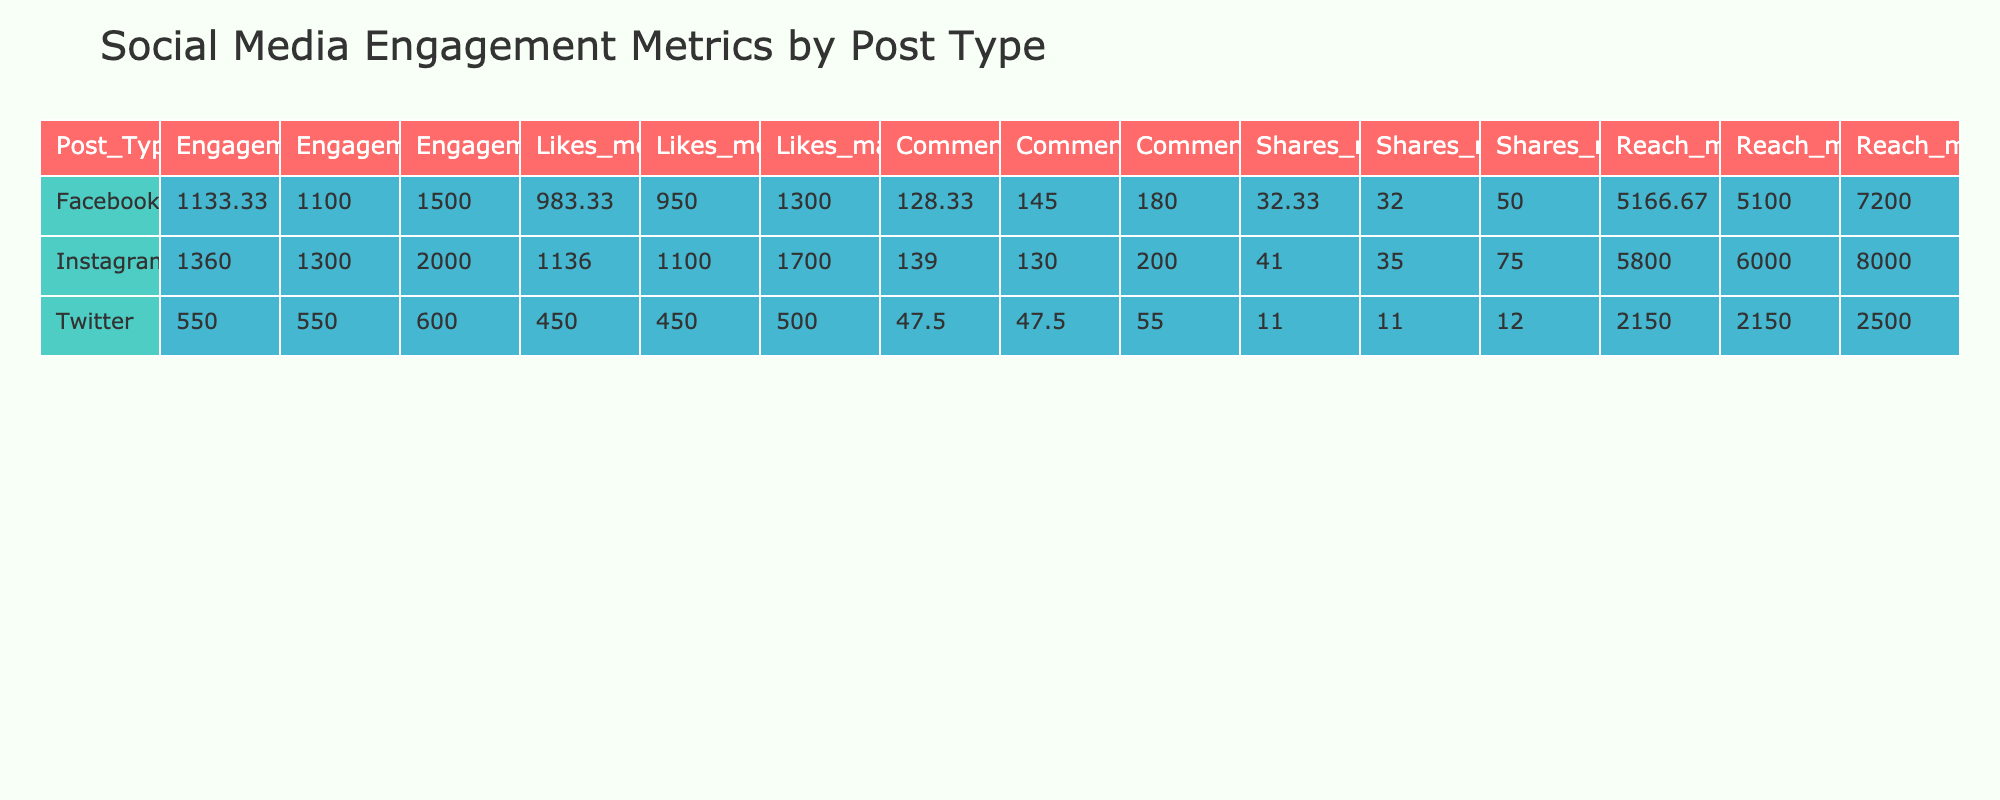What were the maximum engagements for posts on Instagram? Looking at the table, the maximum engagements under the Instagram post type is found in the row for "Kensington Market's Hidden Murals," which has 2000 engagements.
Answer: 2000 What is the average number of likes for Facebook posts? To find the average likes, we need to sum the likes for Facebook posts: 700 + 1300 + 950 = 2950. Then we divide by the number of Facebook posts, which is 3. So, 2950 / 3 = 983.33, rounded to 983.
Answer: 983 Was the maximum reach for posts on Twitter greater than or equal to 3000? The maximum reach for posts on Twitter, as seen in the table, is 2500 (from "The Lost Streets of Chicago"). Since 2500 is less than 3000, the answer is no.
Answer: No Which post type had the highest median number of shares? In the table, the shares for Instagram posts are 75, 30, 45, 20, and 35. When ordered, the median value of shares for Instagram (third value in order) is 45. For Facebook, the shares are 15, 50, and 32, giving a median of 32. Thus, Instagram with a median of 45 is higher.
Answer: Instagram What is the total engagement for all posts created in September 2023? To find the total engagement for posts created in September, we look at the dates: 1200 + 1400 + 2000 + 900 + 1300 = 5800. This is the sum of engagements for posts from September (IDs 1, 3, 5, 8, and 10).
Answer: 5800 Is the average number of comments for all posts greater than 100? First, we calculate the average number of comments. The comments for all posts are: 120 + 60 + 150 + 40 + 200 + 180 + 55 + 95 + 145 + 130. Adding these gives 1130 and dividing by 10 shows that the average is 113. Thus, it is greater than 100.
Answer: Yes What was the reach of the post with the highest number of likes? The post with the highest number of likes is "Kensington Market's Hidden Murals," which has 1700 likes. Checking the table, this post has a reach of 8000.
Answer: 8000 Which post type had fewer total engagements, Instagram or Facebook? Total engagements for Instagram are 1200 + 1400 + 2000 + 900 + 1300 = 6800. For Facebook, they are 800 + 1500 + 1100 = 3400. Since 3400 is less than 6800, Facebook has fewer total engagements.
Answer: Facebook What is the difference in average reach between Instagram and Twitter posts? Average reach for Instagram posts is (5000 + 6000 + 8000 + 4000 + 6000) / 5 = 6200. For Twitter, it is (1800 + 2500) / 2 = 2150. Therefore, the difference is 6200 - 2150 = 4050.
Answer: 4050 